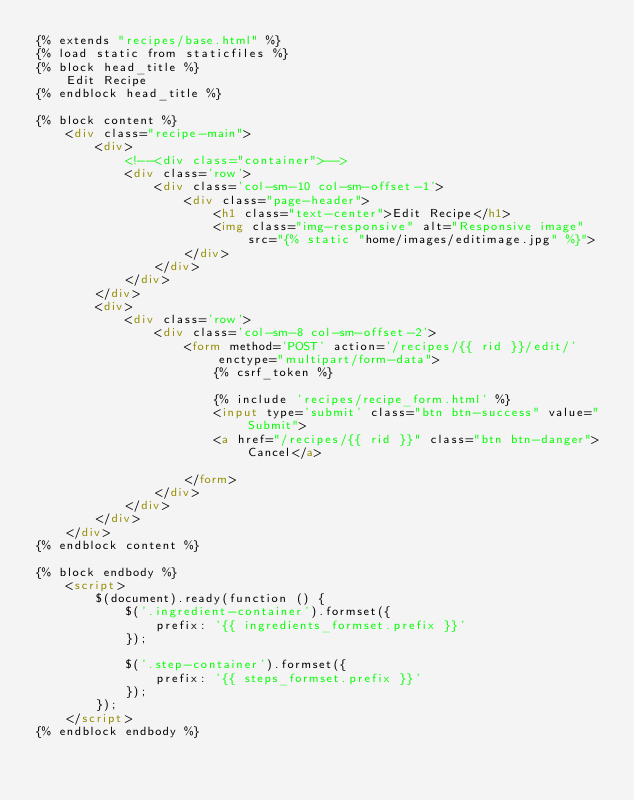Convert code to text. <code><loc_0><loc_0><loc_500><loc_500><_HTML_>{% extends "recipes/base.html" %}
{% load static from staticfiles %}
{% block head_title %}
    Edit Recipe
{% endblock head_title %}

{% block content %}
    <div class="recipe-main">
        <div>
            <!--<div class="container">-->
            <div class='row'>
                <div class='col-sm-10 col-sm-offset-1'>
                    <div class="page-header">
                        <h1 class="text-center">Edit Recipe</h1>
                        <img class="img-responsive" alt="Responsive image" src="{% static "home/images/editimage.jpg" %}">
                    </div>
                </div>
            </div>
        </div>
        <div>
            <div class='row'>
                <div class='col-sm-8 col-sm-offset-2'>
                    <form method='POST' action='/recipes/{{ rid }}/edit/' enctype="multipart/form-data">
                        {% csrf_token %}

                        {% include 'recipes/recipe_form.html' %}
                        <input type='submit' class="btn btn-success" value="Submit">
                        <a href="/recipes/{{ rid }}" class="btn btn-danger">Cancel</a>
                       
                    </form>
                </div>
            </div>
        </div>
    </div>
{% endblock content %}

{% block endbody %}
    <script>
        $(document).ready(function () {
            $('.ingredient-container').formset({
                prefix: '{{ ingredients_formset.prefix }}'
            });

            $('.step-container').formset({
                prefix: '{{ steps_formset.prefix }}'
            });
        });
    </script>
{% endblock endbody %}</code> 